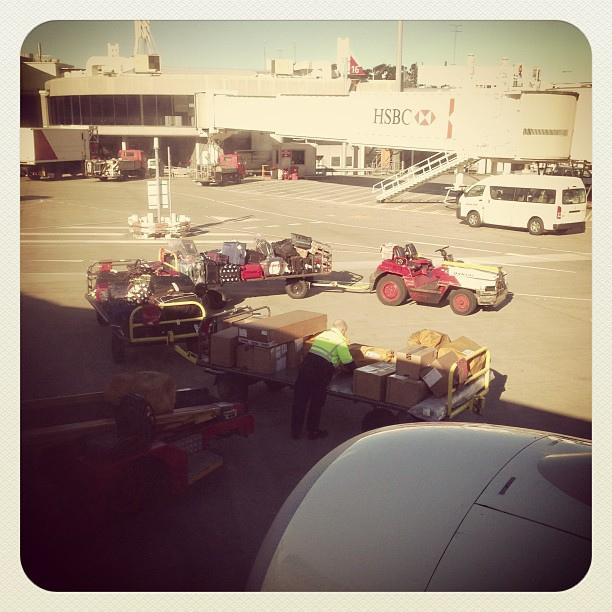What is the big item in the far back right? Please explain your reasoning. van. The vehicle transports large groups of people or objects. 